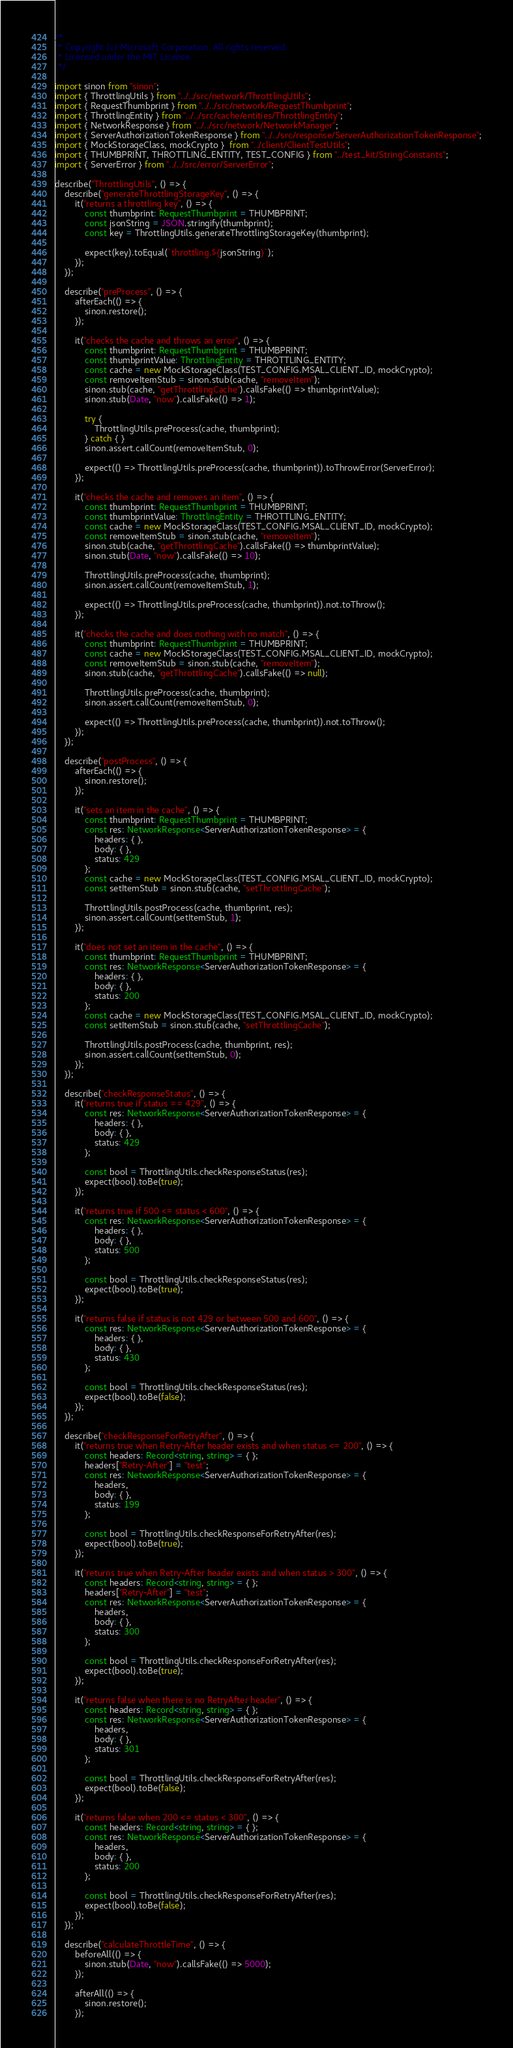<code> <loc_0><loc_0><loc_500><loc_500><_TypeScript_>/*
 * Copyright (c) Microsoft Corporation. All rights reserved.
 * Licensed under the MIT License.
 */

import sinon from "sinon";
import { ThrottlingUtils } from "../../src/network/ThrottlingUtils";
import { RequestThumbprint } from "../../src/network/RequestThumbprint";
import { ThrottlingEntity } from "../../src/cache/entities/ThrottlingEntity";
import { NetworkResponse } from "../../src/network/NetworkManager";
import { ServerAuthorizationTokenResponse } from "../../src/response/ServerAuthorizationTokenResponse";
import { MockStorageClass, mockCrypto }  from "../client/ClientTestUtils";
import { THUMBPRINT, THROTTLING_ENTITY, TEST_CONFIG } from "../test_kit/StringConstants";
import { ServerError } from "../../src/error/ServerError";

describe("ThrottlingUtils", () => {
    describe("generateThrottlingStorageKey", () => {
        it("returns a throttling key", () => {
            const thumbprint: RequestThumbprint = THUMBPRINT;
            const jsonString = JSON.stringify(thumbprint);
            const key = ThrottlingUtils.generateThrottlingStorageKey(thumbprint);

            expect(key).toEqual(`throttling.${jsonString}`);
        });
    });

    describe("preProcess", () => {
        afterEach(() => {
            sinon.restore();
        });

        it("checks the cache and throws an error", () => {
            const thumbprint: RequestThumbprint = THUMBPRINT;
            const thumbprintValue: ThrottlingEntity = THROTTLING_ENTITY;
            const cache = new MockStorageClass(TEST_CONFIG.MSAL_CLIENT_ID, mockCrypto);
            const removeItemStub = sinon.stub(cache, "removeItem");
            sinon.stub(cache, "getThrottlingCache").callsFake(() => thumbprintValue);
            sinon.stub(Date, "now").callsFake(() => 1);

            try {
                ThrottlingUtils.preProcess(cache, thumbprint);
            } catch { }
            sinon.assert.callCount(removeItemStub, 0);

            expect(() => ThrottlingUtils.preProcess(cache, thumbprint)).toThrowError(ServerError);
        });

        it("checks the cache and removes an item", () => {
            const thumbprint: RequestThumbprint = THUMBPRINT;
            const thumbprintValue: ThrottlingEntity = THROTTLING_ENTITY;
            const cache = new MockStorageClass(TEST_CONFIG.MSAL_CLIENT_ID, mockCrypto);
            const removeItemStub = sinon.stub(cache, "removeItem");
            sinon.stub(cache, "getThrottlingCache").callsFake(() => thumbprintValue);
            sinon.stub(Date, "now").callsFake(() => 10);

            ThrottlingUtils.preProcess(cache, thumbprint);
            sinon.assert.callCount(removeItemStub, 1);

            expect(() => ThrottlingUtils.preProcess(cache, thumbprint)).not.toThrow();
        });

        it("checks the cache and does nothing with no match", () => {
            const thumbprint: RequestThumbprint = THUMBPRINT;
            const cache = new MockStorageClass(TEST_CONFIG.MSAL_CLIENT_ID, mockCrypto);
            const removeItemStub = sinon.stub(cache, "removeItem");
            sinon.stub(cache, "getThrottlingCache").callsFake(() => null);

            ThrottlingUtils.preProcess(cache, thumbprint);
            sinon.assert.callCount(removeItemStub, 0);

            expect(() => ThrottlingUtils.preProcess(cache, thumbprint)).not.toThrow();
        });
    });

    describe("postProcess", () => {
        afterEach(() => {
            sinon.restore();
        });

        it("sets an item in the cache", () => {
            const thumbprint: RequestThumbprint = THUMBPRINT;
            const res: NetworkResponse<ServerAuthorizationTokenResponse> = {
                headers: { },
                body: { },
                status: 429
            };
            const cache = new MockStorageClass(TEST_CONFIG.MSAL_CLIENT_ID, mockCrypto);
            const setItemStub = sinon.stub(cache, "setThrottlingCache");

            ThrottlingUtils.postProcess(cache, thumbprint, res);
            sinon.assert.callCount(setItemStub, 1);
        });

        it("does not set an item in the cache", () => {
            const thumbprint: RequestThumbprint = THUMBPRINT;
            const res: NetworkResponse<ServerAuthorizationTokenResponse> = {
                headers: { },
                body: { },
                status: 200
            };
            const cache = new MockStorageClass(TEST_CONFIG.MSAL_CLIENT_ID, mockCrypto);
            const setItemStub = sinon.stub(cache, "setThrottlingCache");

            ThrottlingUtils.postProcess(cache, thumbprint, res);
            sinon.assert.callCount(setItemStub, 0);
        });
    });

    describe("checkResponseStatus", () => {
        it("returns true if status == 429", () => {
            const res: NetworkResponse<ServerAuthorizationTokenResponse> = {
                headers: { },
                body: { },
                status: 429
            };

            const bool = ThrottlingUtils.checkResponseStatus(res);
            expect(bool).toBe(true);
        });

        it("returns true if 500 <= status < 600", () => {
            const res: NetworkResponse<ServerAuthorizationTokenResponse> = {
                headers: { },
                body: { },
                status: 500
            };

            const bool = ThrottlingUtils.checkResponseStatus(res);
            expect(bool).toBe(true);
        });

        it("returns false if status is not 429 or between 500 and 600", () => {
            const res: NetworkResponse<ServerAuthorizationTokenResponse> = {
                headers: { },
                body: { },
                status: 430
            };

            const bool = ThrottlingUtils.checkResponseStatus(res);
            expect(bool).toBe(false);
        });
    });

    describe("checkResponseForRetryAfter", () => {
        it("returns true when Retry-After header exists and when status <= 200", () => {
            const headers: Record<string, string> = { };
            headers["Retry-After"] = "test";
            const res: NetworkResponse<ServerAuthorizationTokenResponse> = {
                headers,
                body: { },
                status: 199
            };

            const bool = ThrottlingUtils.checkResponseForRetryAfter(res);
            expect(bool).toBe(true);
        });

        it("returns true when Retry-After header exists and when status > 300", () => {
            const headers: Record<string, string> = { };
            headers["Retry-After"] = "test";
            const res: NetworkResponse<ServerAuthorizationTokenResponse> = {
                headers,
                body: { },
                status: 300
            };

            const bool = ThrottlingUtils.checkResponseForRetryAfter(res);
            expect(bool).toBe(true);
        });

        it("returns false when there is no RetryAfter header", () => {
            const headers: Record<string, string> = { };
            const res: NetworkResponse<ServerAuthorizationTokenResponse> = {
                headers,
                body: { },
                status: 301
            };

            const bool = ThrottlingUtils.checkResponseForRetryAfter(res);
            expect(bool).toBe(false);
        });

        it("returns false when 200 <= status < 300", () => {
            const headers: Record<string, string> = { };
            const res: NetworkResponse<ServerAuthorizationTokenResponse> = {
                headers,
                body: { },
                status: 200
            };

            const bool = ThrottlingUtils.checkResponseForRetryAfter(res);
            expect(bool).toBe(false);
        });
    });

    describe("calculateThrottleTime", () => {
        beforeAll(() => {
            sinon.stub(Date, "now").callsFake(() => 5000);
        });

        afterAll(() => {
            sinon.restore();
        });
</code> 